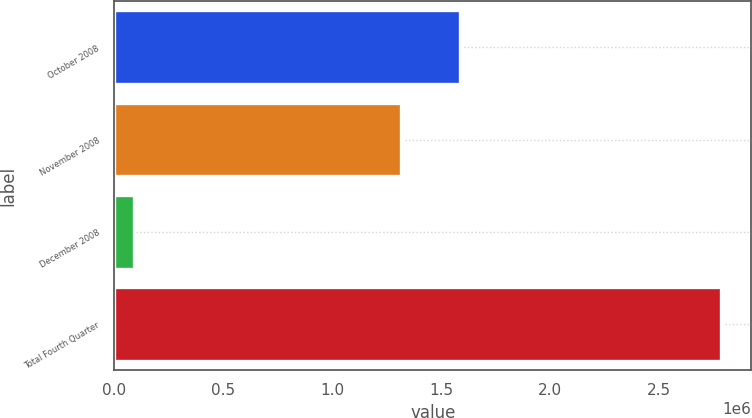Convert chart to OTSL. <chart><loc_0><loc_0><loc_500><loc_500><bar_chart><fcel>October 2008<fcel>November 2008<fcel>December 2008<fcel>Total Fourth Quarter<nl><fcel>1.5853e+06<fcel>1.3158e+06<fcel>89241<fcel>2.78422e+06<nl></chart> 